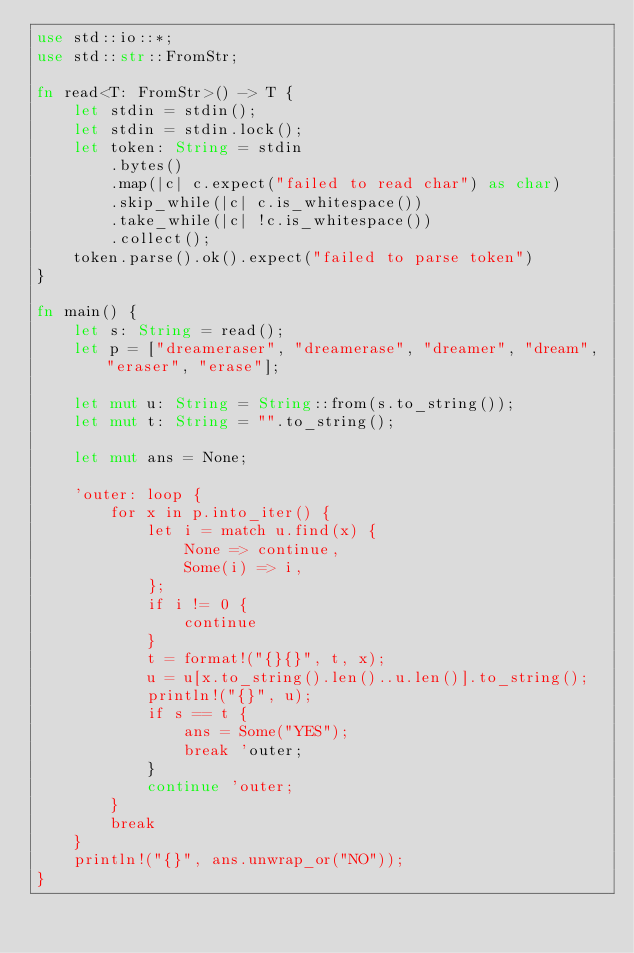<code> <loc_0><loc_0><loc_500><loc_500><_Rust_>use std::io::*;
use std::str::FromStr;

fn read<T: FromStr>() -> T {
    let stdin = stdin();
    let stdin = stdin.lock();
    let token: String = stdin
        .bytes()
        .map(|c| c.expect("failed to read char") as char) 
        .skip_while(|c| c.is_whitespace())
        .take_while(|c| !c.is_whitespace())
        .collect();
    token.parse().ok().expect("failed to parse token")
}

fn main() {
    let s: String = read();
    let p = ["dreameraser", "dreamerase", "dreamer", "dream", "eraser", "erase"];

    let mut u: String = String::from(s.to_string());
    let mut t: String = "".to_string();

    let mut ans = None;

    'outer: loop {
        for x in p.into_iter() {
            let i = match u.find(x) {
                None => continue,
                Some(i) => i,
            };
            if i != 0 {
                continue
            }
            t = format!("{}{}", t, x);
            u = u[x.to_string().len()..u.len()].to_string();
            println!("{}", u);
            if s == t {
                ans = Some("YES");
                break 'outer;
            }
            continue 'outer;
        }
        break
    }
    println!("{}", ans.unwrap_or("NO"));
}
</code> 